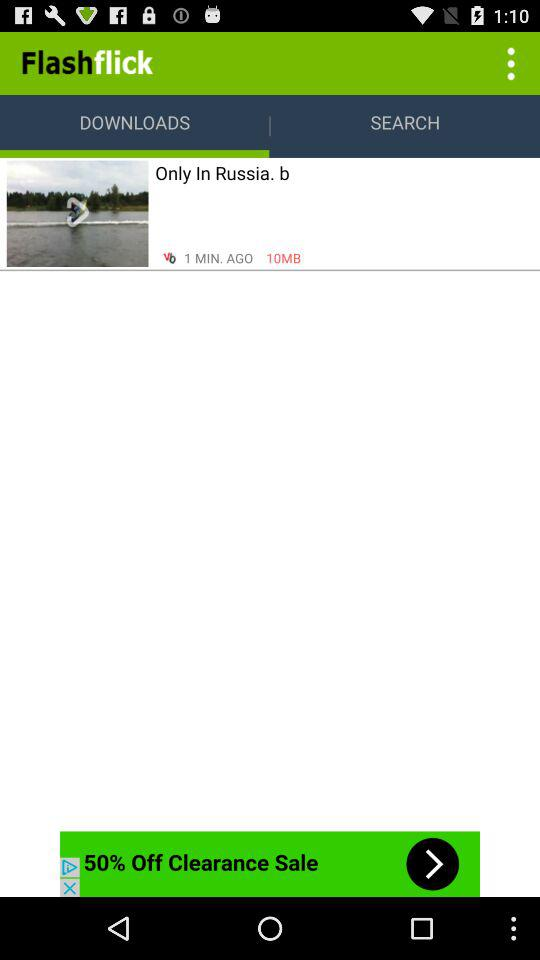When was the last search made?
When the provided information is insufficient, respond with <no answer>. <no answer> 